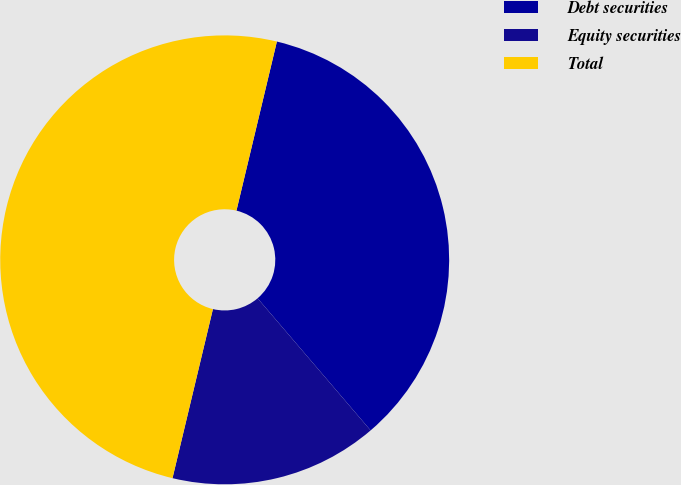<chart> <loc_0><loc_0><loc_500><loc_500><pie_chart><fcel>Debt securities<fcel>Equity securities<fcel>Total<nl><fcel>35.0%<fcel>15.0%<fcel>50.0%<nl></chart> 